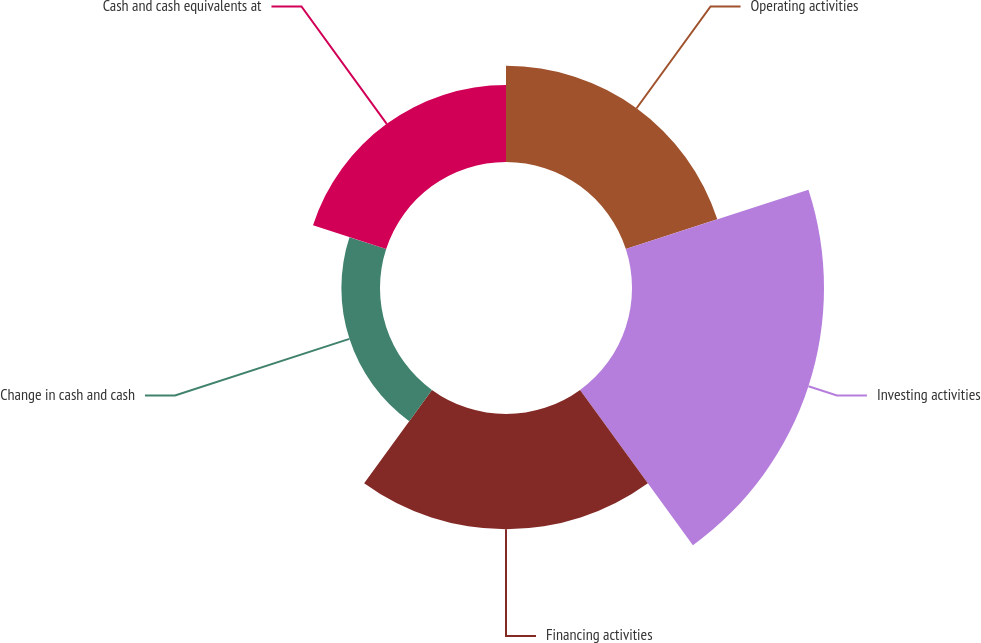Convert chart to OTSL. <chart><loc_0><loc_0><loc_500><loc_500><pie_chart><fcel>Operating activities<fcel>Investing activities<fcel>Financing activities<fcel>Change in cash and cash<fcel>Cash and cash equivalents at<nl><fcel>18.53%<fcel>36.99%<fcel>22.22%<fcel>7.44%<fcel>14.82%<nl></chart> 